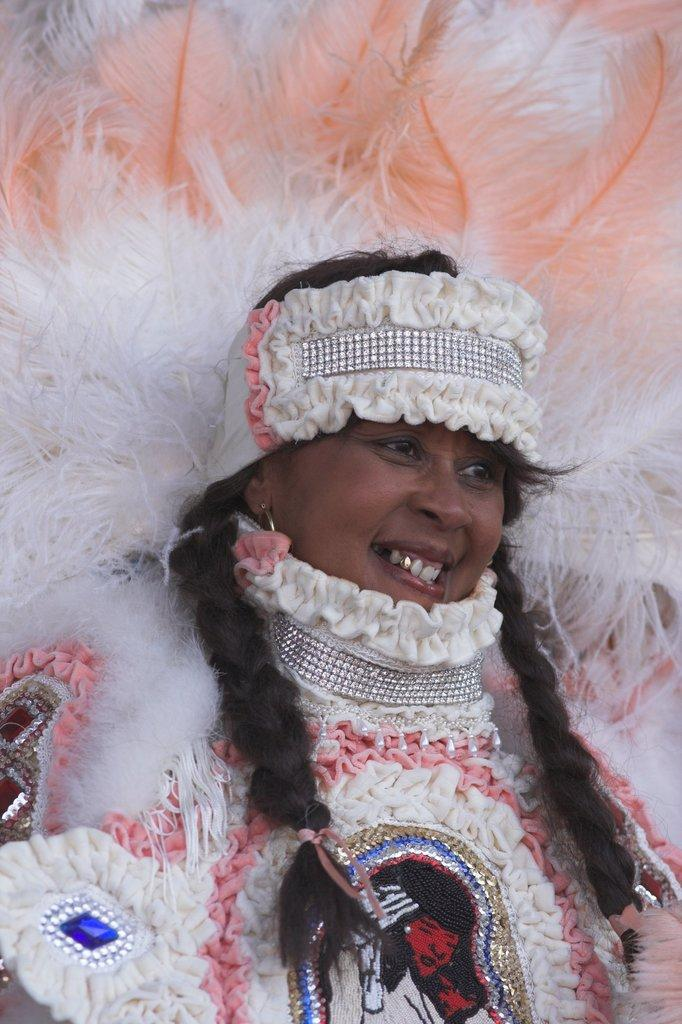Who is the main subject in the image? There is a woman in the image. What is the woman wearing? The woman is wearing a white dress. What is the woman doing in the image? The woman is standing. What type of headwear is the woman wearing? The woman is wearing a costume hat. What is the reason for the mark on the woman's face in the image? There is no mark on the woman's face in the image. 